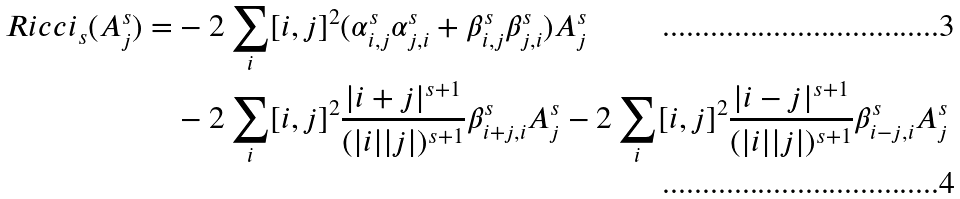Convert formula to latex. <formula><loc_0><loc_0><loc_500><loc_500>R i c c i _ { s } ( A ^ { s } _ { j } ) = & - 2 \sum _ { i } [ i , j ] ^ { 2 } ( \alpha ^ { s } _ { i , j } \alpha ^ { s } _ { j , i } + \beta ^ { s } _ { i , j } \beta ^ { s } _ { j , i } ) A ^ { s } _ { j } \\ & - 2 \sum _ { i } [ i , j ] ^ { 2 } \frac { | i + j | ^ { s + 1 } } { ( | i | | j | ) ^ { s + 1 } } \beta ^ { s } _ { i + j , i } A ^ { s } _ { j } - 2 \sum _ { i } [ i , j ] ^ { 2 } \frac { | i - j | ^ { s + 1 } } { ( | i | | j | ) ^ { s + 1 } } \beta ^ { s } _ { i - j , i } A ^ { s } _ { j }</formula> 